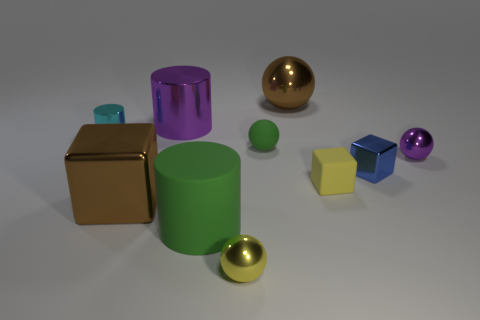Can you describe the lighting in the scene? The lighting appears to be coming from above, given the shadows cast directly underneath objects. The strength of the light is moderate, neither too harsh nor too dim, softly illuminating the objects and revealing their colors and textures. 